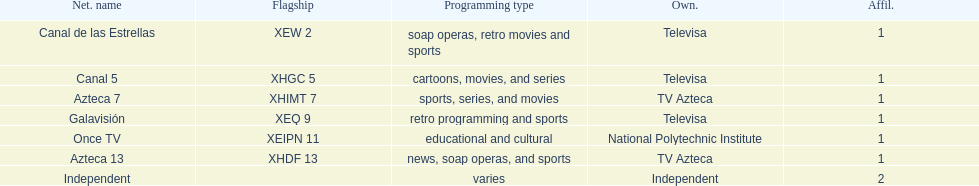Give me the full table as a dictionary. {'header': ['Net. name', 'Flagship', 'Programming type', 'Own.', 'Affil.'], 'rows': [['Canal de las Estrellas', 'XEW 2', 'soap operas, retro movies and sports', 'Televisa', '1'], ['Canal 5', 'XHGC 5', 'cartoons, movies, and series', 'Televisa', '1'], ['Azteca 7', 'XHIMT 7', 'sports, series, and movies', 'TV Azteca', '1'], ['Galavisión', 'XEQ 9', 'retro programming and sports', 'Televisa', '1'], ['Once TV', 'XEIPN 11', 'educational and cultural', 'National Polytechnic Institute', '1'], ['Azteca 13', 'XHDF 13', 'news, soap operas, and sports', 'TV Azteca', '1'], ['Independent', '', 'varies', 'Independent', '2']]} What is the difference between the number of affiliates galavision has and the number of affiliates azteca 13 has? 0. 